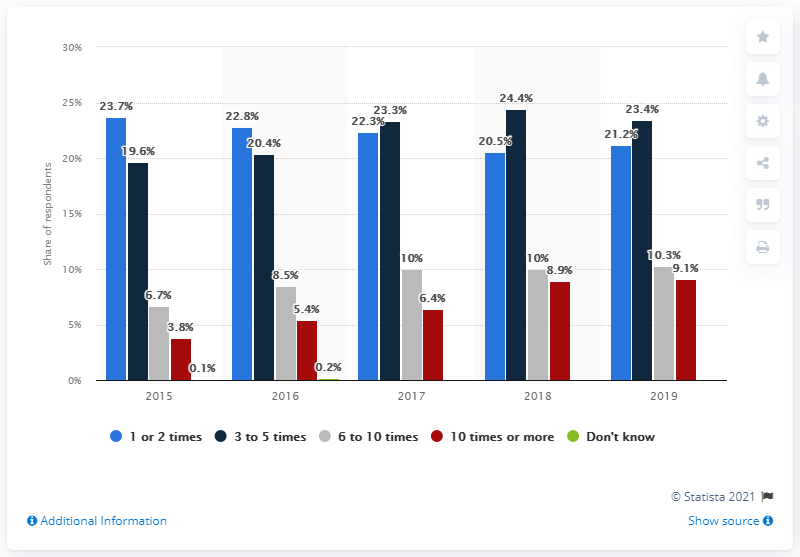Identify some key points in this picture. The average of all red bars is 6.72... The data originates from the country of the Netherlands. 